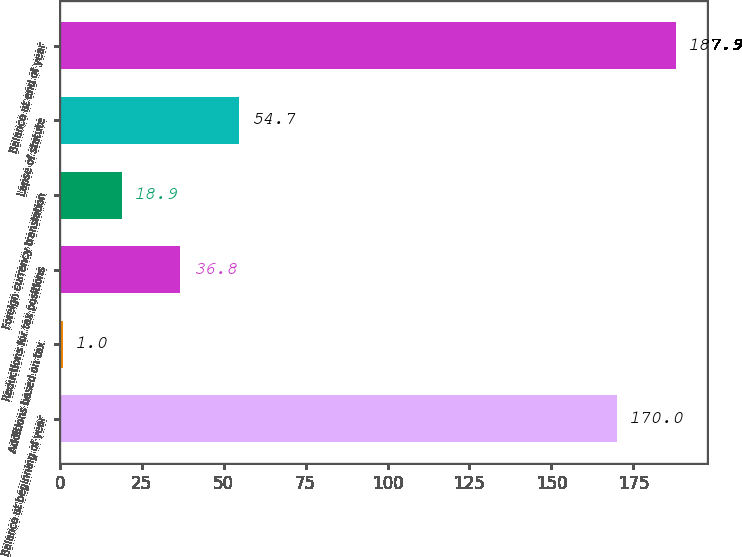Convert chart. <chart><loc_0><loc_0><loc_500><loc_500><bar_chart><fcel>Balance at beginning of year<fcel>Additions based on tax<fcel>Reductions for tax positions<fcel>Foreign currency translation<fcel>Lapse of statute<fcel>Balance at end of year<nl><fcel>170<fcel>1<fcel>36.8<fcel>18.9<fcel>54.7<fcel>187.9<nl></chart> 